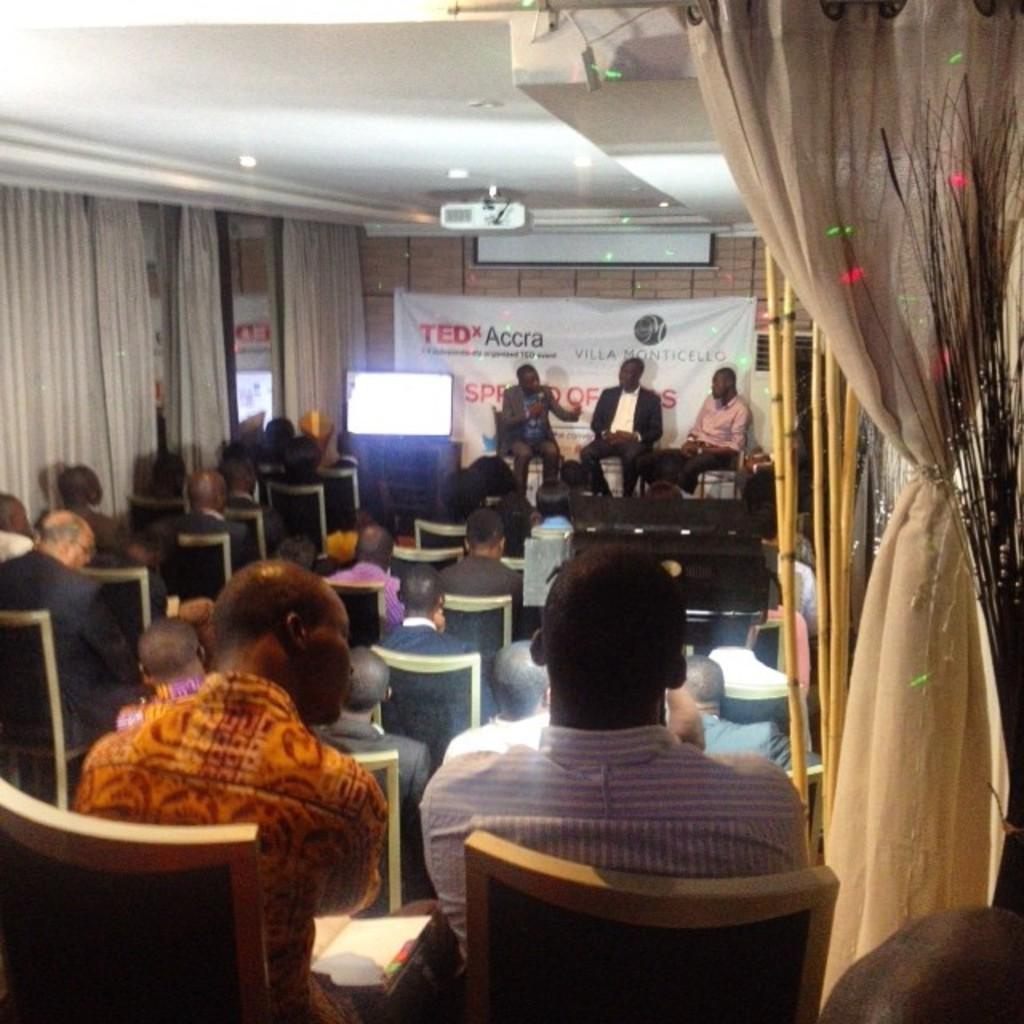Could you give a brief overview of what you see in this image? In this image there are group of persons sitting on a chair. In the background there is a banner with some text written on it and in front of the banner there is a monitor and at the top there is a projector. On the right side in the front there is a curtain and there are poles. On the left side there are curtains. 